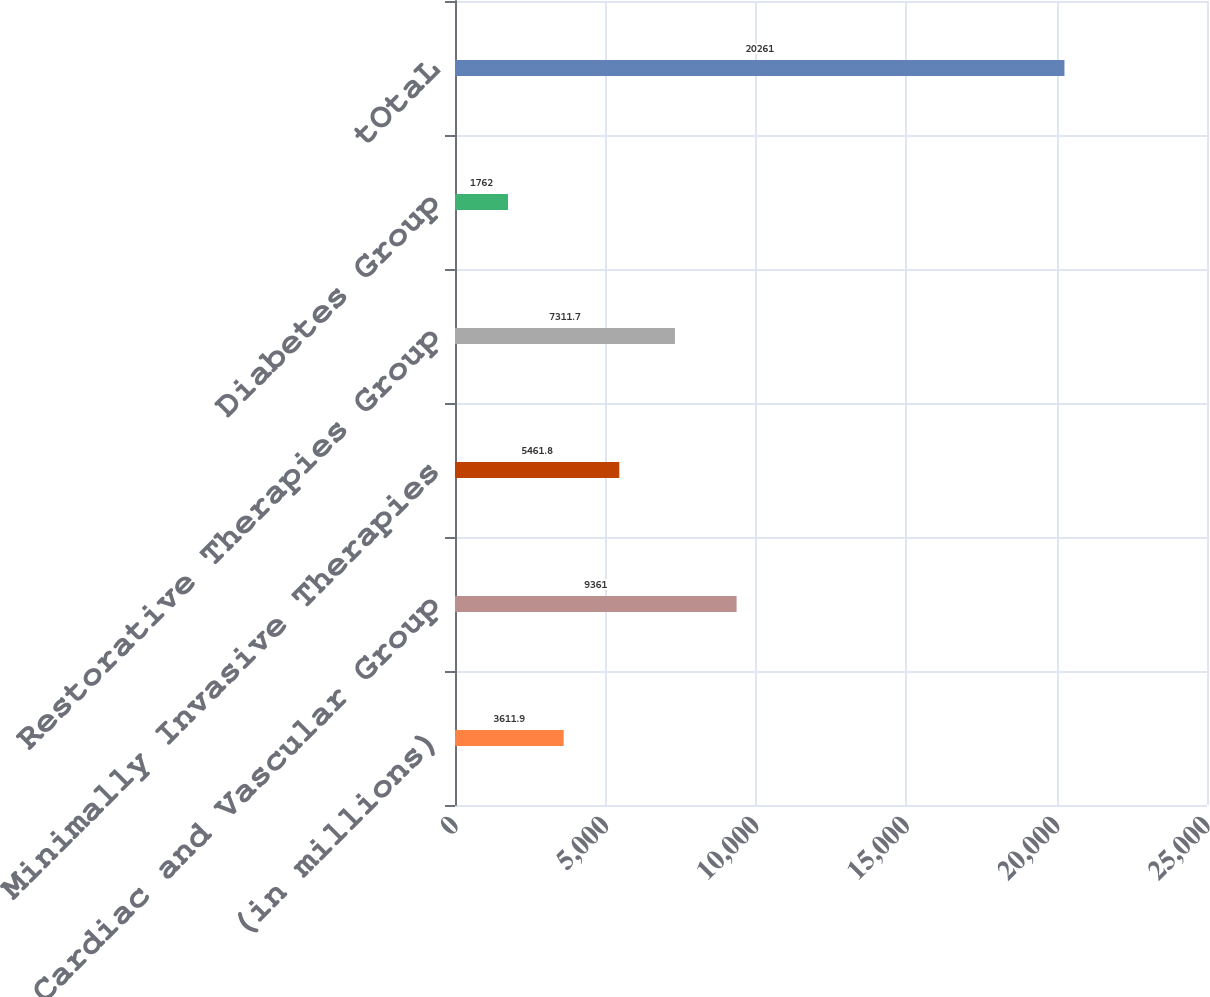<chart> <loc_0><loc_0><loc_500><loc_500><bar_chart><fcel>(in millions)<fcel>Cardiac and Vascular Group<fcel>Minimally Invasive Therapies<fcel>Restorative Therapies Group<fcel>Diabetes Group<fcel>tOtaL<nl><fcel>3611.9<fcel>9361<fcel>5461.8<fcel>7311.7<fcel>1762<fcel>20261<nl></chart> 